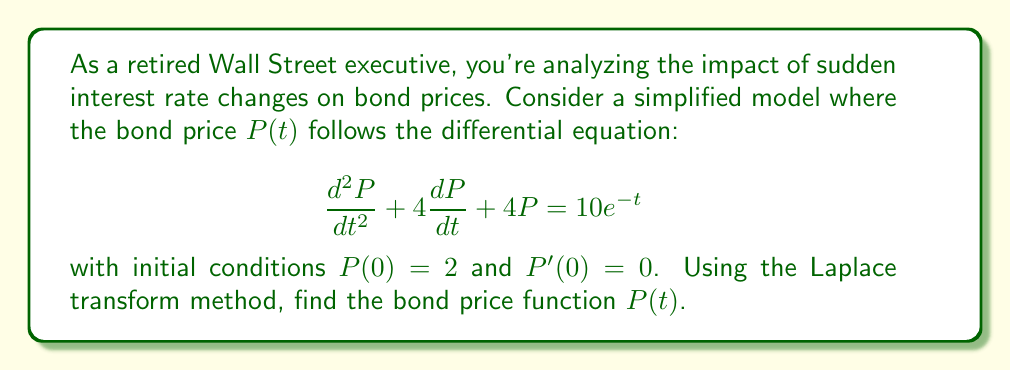Solve this math problem. Let's solve this using the Laplace transform method:

1) Take the Laplace transform of both sides of the equation:
   $$\mathcal{L}\{P''(t) + 4P'(t) + 4P(t)\} = \mathcal{L}\{10e^{-t}\}$$

2) Using Laplace transform properties:
   $$(s^2\mathcal{L}\{P(t)\} - sP(0) - P'(0)) + 4(s\mathcal{L}\{P(t)\} - P(0)) + 4\mathcal{L}\{P(t)\} = \frac{10}{s+1}$$

3) Let $\mathcal{L}\{P(t)\} = X(s)$. Substituting the initial conditions:
   $$(s^2X(s) - 2s - 0) + 4(sX(s) - 2) + 4X(s) = \frac{10}{s+1}$$

4) Simplify:
   $$s^2X(s) + 4sX(s) + 4X(s) - 2s - 8 = \frac{10}{s+1}$$
   $$(s^2 + 4s + 4)X(s) = \frac{10}{s+1} + 2s + 8$$

5) Solve for $X(s)$:
   $$X(s) = \frac{10}{(s+1)(s^2 + 4s + 4)} + \frac{2s + 8}{s^2 + 4s + 4}$$

6) Decompose into partial fractions:
   $$X(s) = \frac{2}{s+1} + \frac{-2}{s+2} + \frac{2}{(s+2)^2}$$

7) Take the inverse Laplace transform:
   $$P(t) = 2e^{-t} - 2e^{-2t} + 2te^{-2t}$$

This is the bond price function $P(t)$.
Answer: $P(t) = 2e^{-t} - 2e^{-2t} + 2te^{-2t}$ 